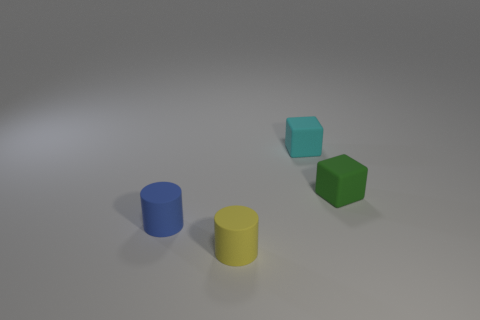How many tiny things have the same material as the cyan block?
Provide a short and direct response. 3. Is there another yellow matte object that has the same shape as the yellow matte thing?
Give a very brief answer. No. There is a blue rubber thing that is the same size as the cyan thing; what shape is it?
Give a very brief answer. Cylinder. What number of small blue matte cylinders are right of the cylinder in front of the tiny blue rubber thing?
Keep it short and to the point. 0. There is a matte object that is both to the left of the small cyan object and to the right of the blue cylinder; what size is it?
Your answer should be compact. Small. Is there another green rubber thing of the same size as the green object?
Offer a very short reply. No. Are there more green blocks left of the tiny green thing than tiny yellow cylinders on the left side of the small yellow object?
Your answer should be very brief. No. Is the material of the yellow cylinder the same as the small object to the left of the yellow matte object?
Offer a terse response. Yes. There is a small cube that is behind the tiny rubber cube on the right side of the tiny cyan rubber block; how many small blue matte cylinders are to the left of it?
Your response must be concise. 1. There is a small yellow object; does it have the same shape as the small rubber object to the left of the yellow matte thing?
Your answer should be very brief. Yes. 